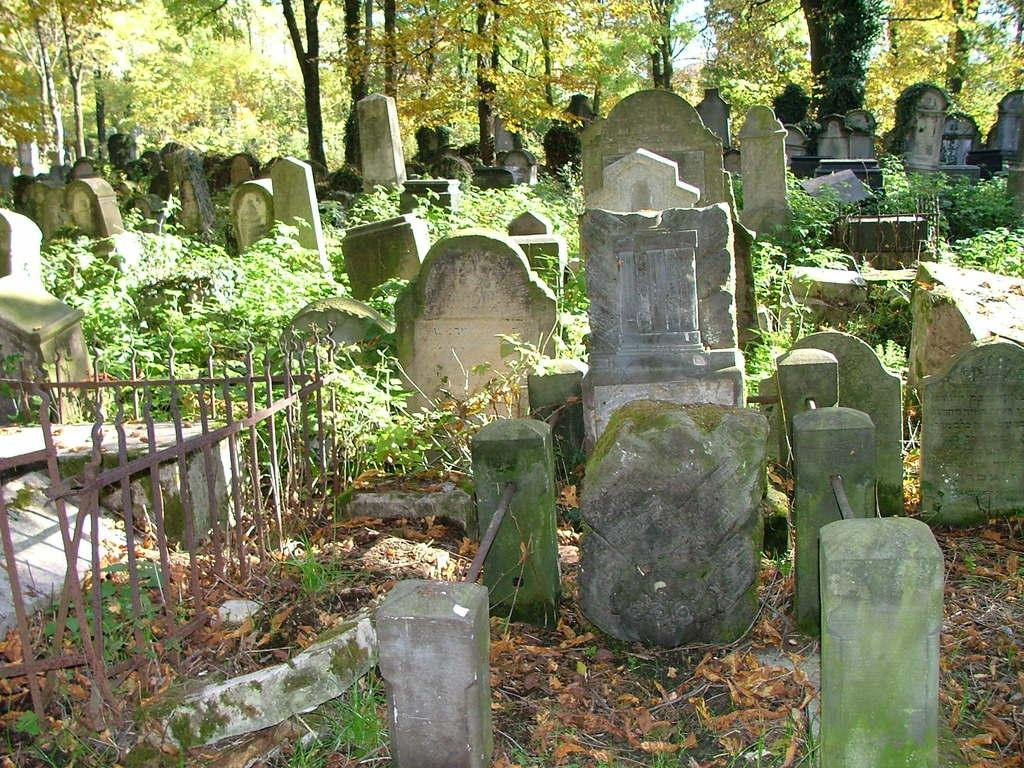What is the main setting of the image? The image depicts a graveyard. What type of vegetation can be seen in the graveyard? There are many plants in the graveyard. What are the markers for the graves in the image? There are memorial stones in the graveyard. What can be seen in the background of the image? There are trees visible in the background of the image. Where is the faucet located in the image? There is no faucet present in the image. What type of joke can be seen on the memorial stones in the image? There are no jokes present on the memorial stones in the image; they are meant to honor and remember the deceased. 